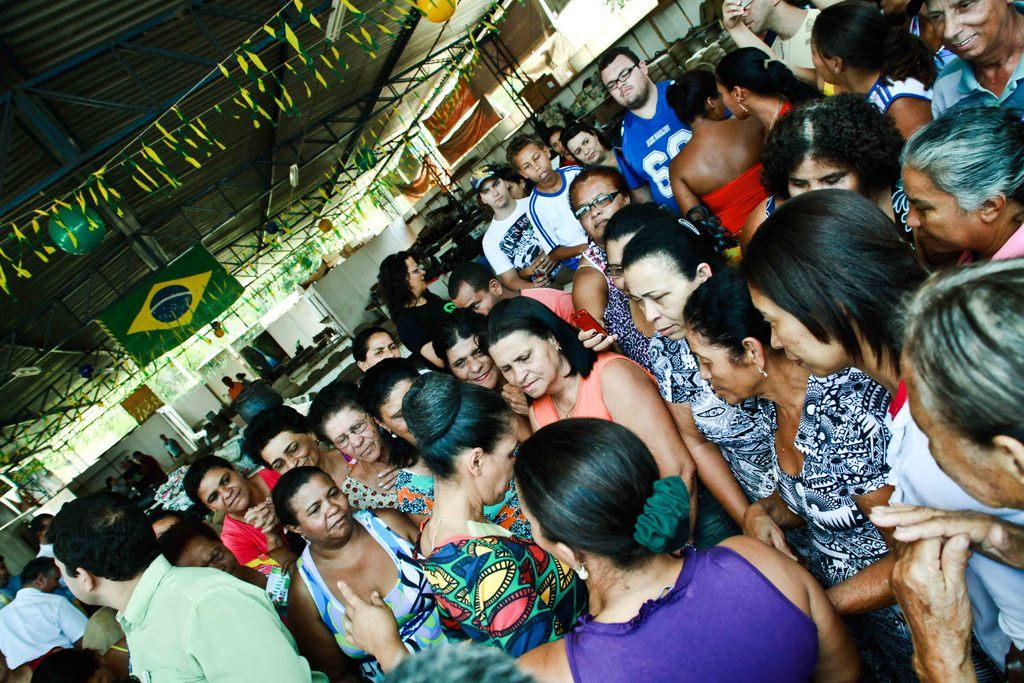What can be seen standing in the foreground of the image? There are people standing in the foreground of the image. What structure is located at the top of the image? There is a shed at the top of the image. What can be seen in the background of the image? There is a building and trees in the background of the image. What type of coil is present in the image? There is no coil present in the image. Can you tell me where the zoo is located in the image? There is no zoo present in the image. 